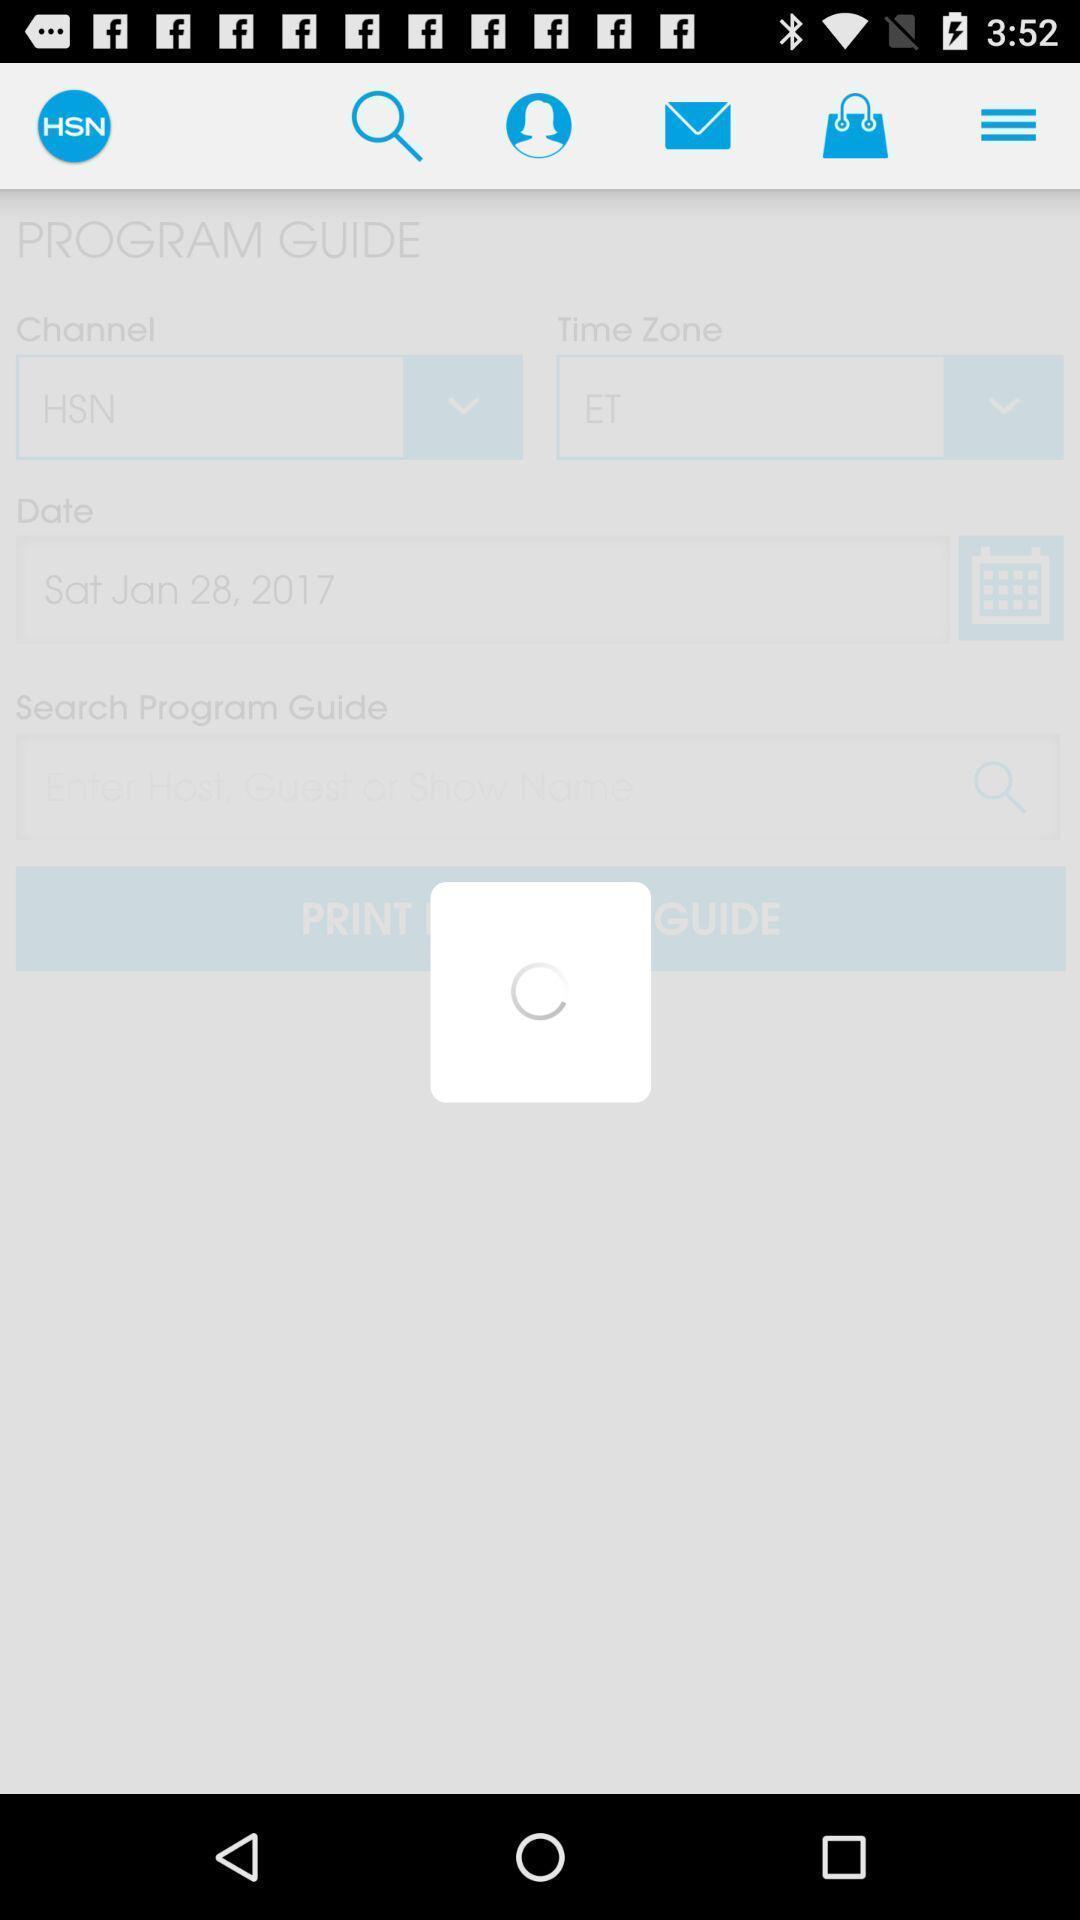Give me a summary of this screen capture. Screen displaying loading page. 